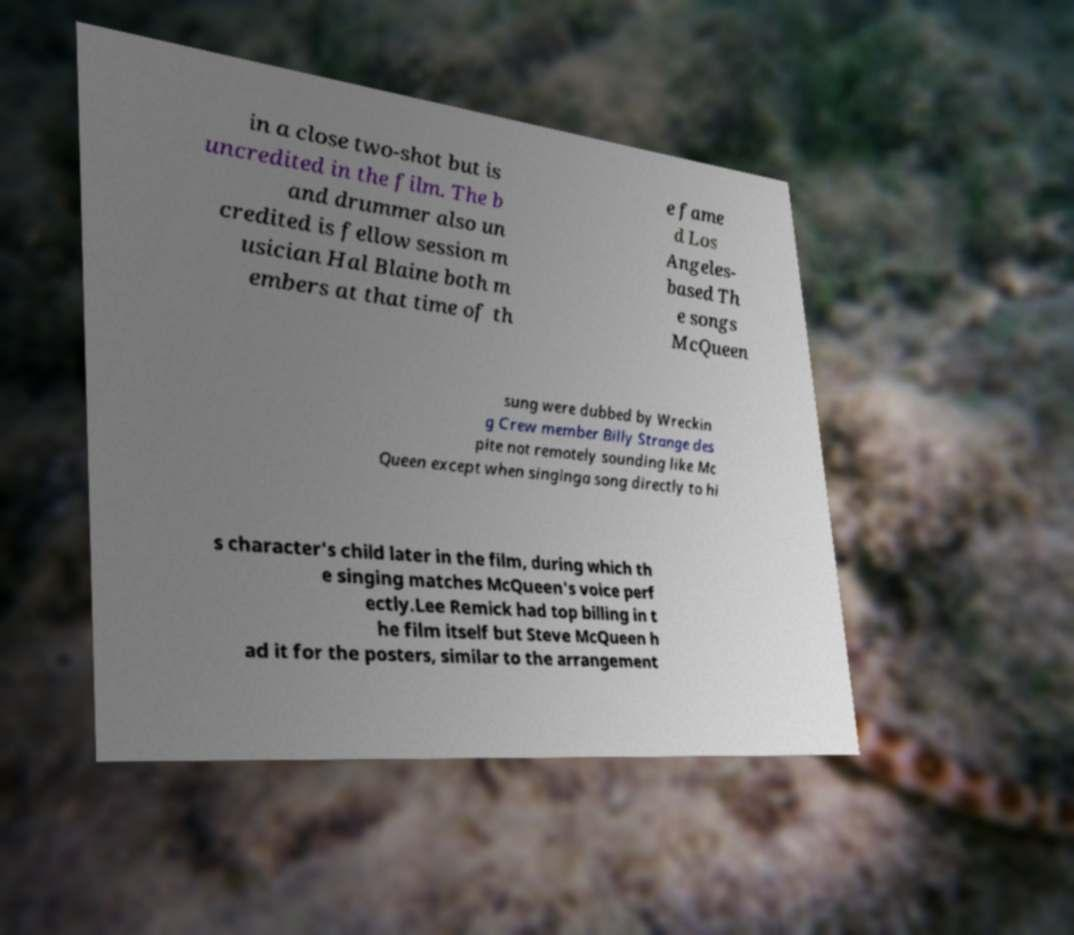Can you accurately transcribe the text from the provided image for me? in a close two-shot but is uncredited in the film. The b and drummer also un credited is fellow session m usician Hal Blaine both m embers at that time of th e fame d Los Angeles- based Th e songs McQueen sung were dubbed by Wreckin g Crew member Billy Strange des pite not remotely sounding like Mc Queen except when singinga song directly to hi s character's child later in the film, during which th e singing matches McQueen's voice perf ectly.Lee Remick had top billing in t he film itself but Steve McQueen h ad it for the posters, similar to the arrangement 